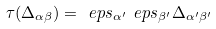Convert formula to latex. <formula><loc_0><loc_0><loc_500><loc_500>\tau ( \Delta _ { \alpha \beta } ) = \ e p s _ { \alpha ^ { \prime } } \ e p s _ { \beta ^ { \prime } } \Delta _ { \alpha ^ { \prime } \beta ^ { \prime } }</formula> 